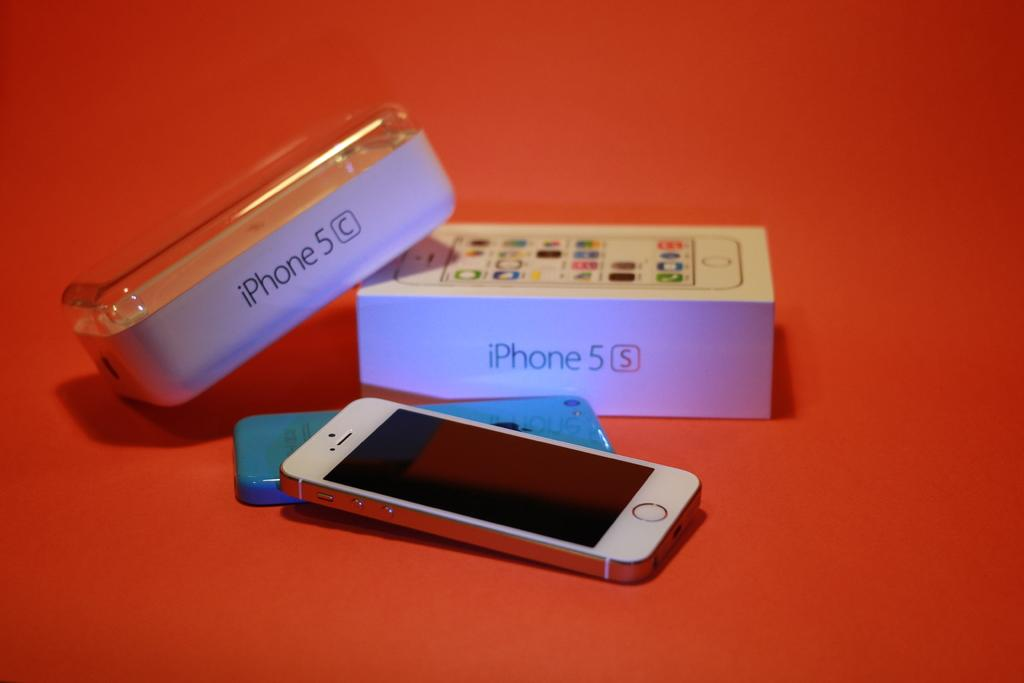<image>
Share a concise interpretation of the image provided. A silver iPhone 5 is switched off and lies on the reverse of the same make of phone in front of its packaging. 